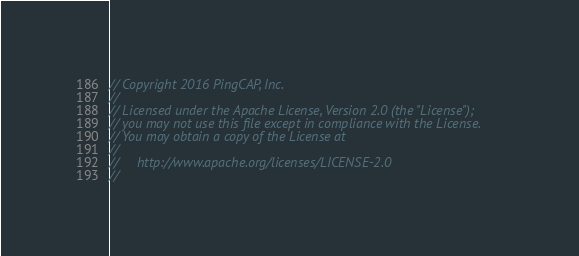<code> <loc_0><loc_0><loc_500><loc_500><_Go_>// Copyright 2016 PingCAP, Inc.
//
// Licensed under the Apache License, Version 2.0 (the "License");
// you may not use this file except in compliance with the License.
// You may obtain a copy of the License at
//
//     http://www.apache.org/licenses/LICENSE-2.0
//</code> 